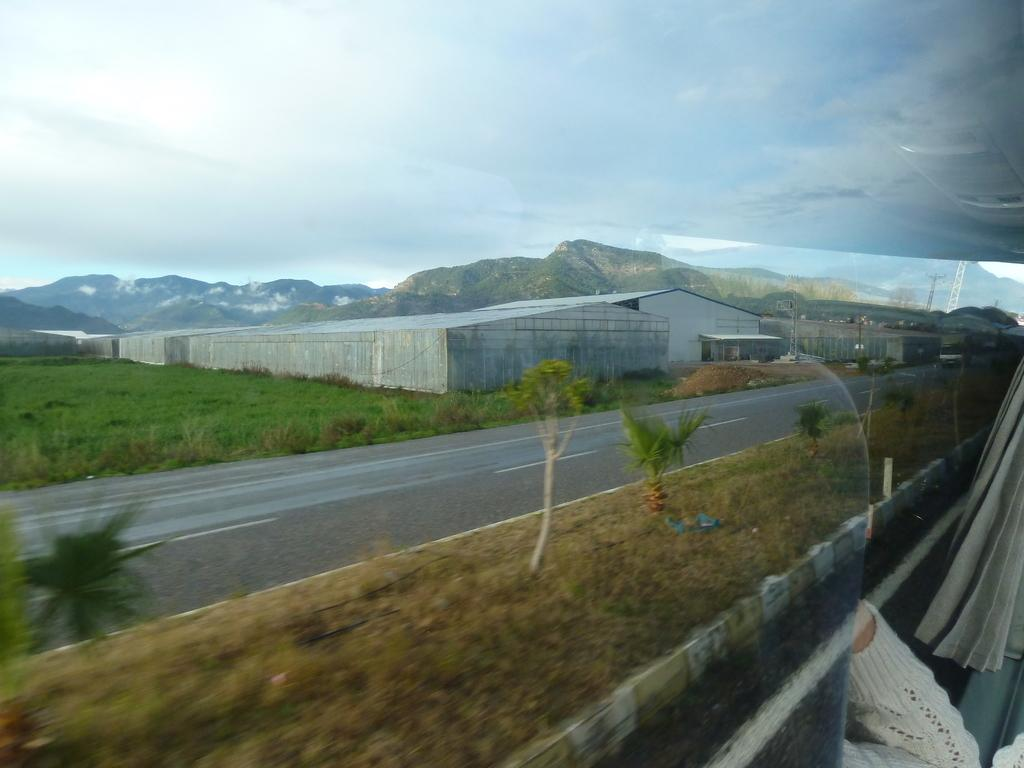What is the main subject of the image? There is a vehicle on the road in the image. What can be seen in the background of the image? There is a poultry farm, greenery on the ground, and mountains in the background of the image. Can you describe the hand of a person in the image? There is a hand of a person in the right corner of the image. What type of bath can be seen in the image? There is no bath present in the image. How many wheels are visible on the vehicle in the image? The number of wheels on the vehicle cannot be determined from the image, as only a part of the vehicle is visible. 